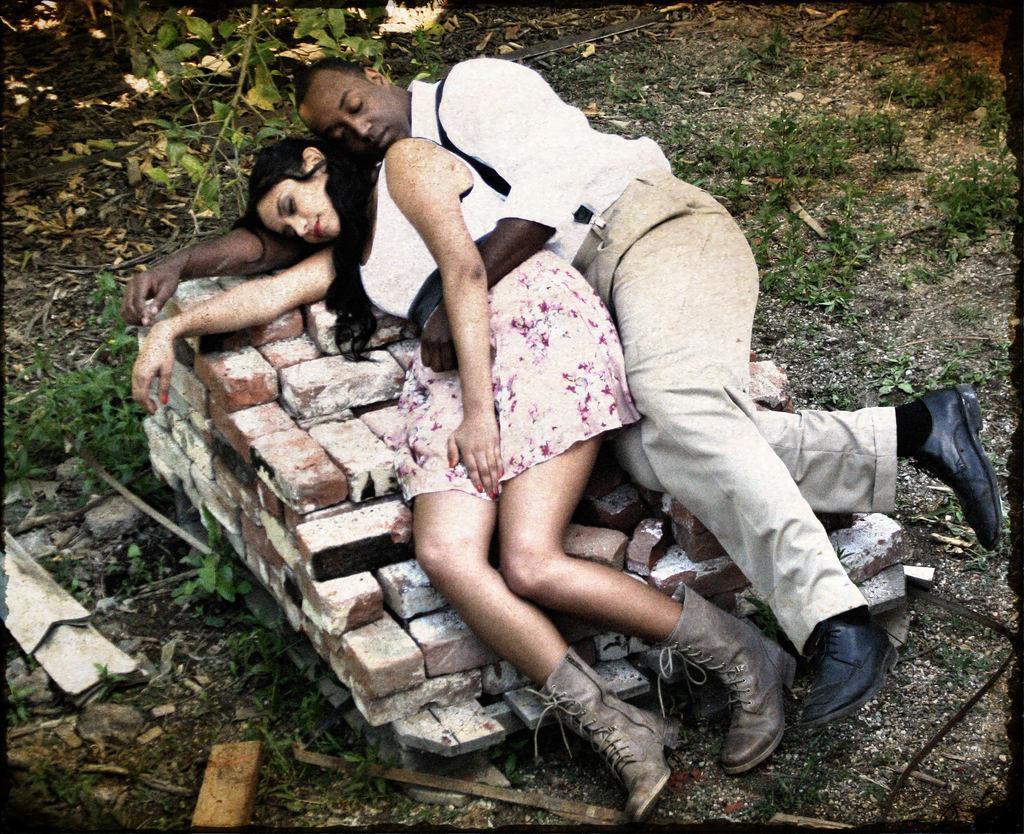Please provide a concise description of this image. In this image we can see a man and a woman lying on the bricks. We can also see the dried leaves and grass on the ground and the image has black borders. 